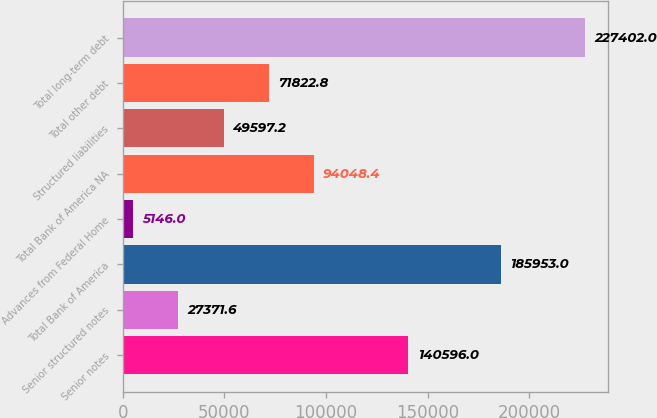Convert chart. <chart><loc_0><loc_0><loc_500><loc_500><bar_chart><fcel>Senior notes<fcel>Senior structured notes<fcel>Total Bank of America<fcel>Advances from Federal Home<fcel>Total Bank of America NA<fcel>Structured liabilities<fcel>Total other debt<fcel>Total long-term debt<nl><fcel>140596<fcel>27371.6<fcel>185953<fcel>5146<fcel>94048.4<fcel>49597.2<fcel>71822.8<fcel>227402<nl></chart> 